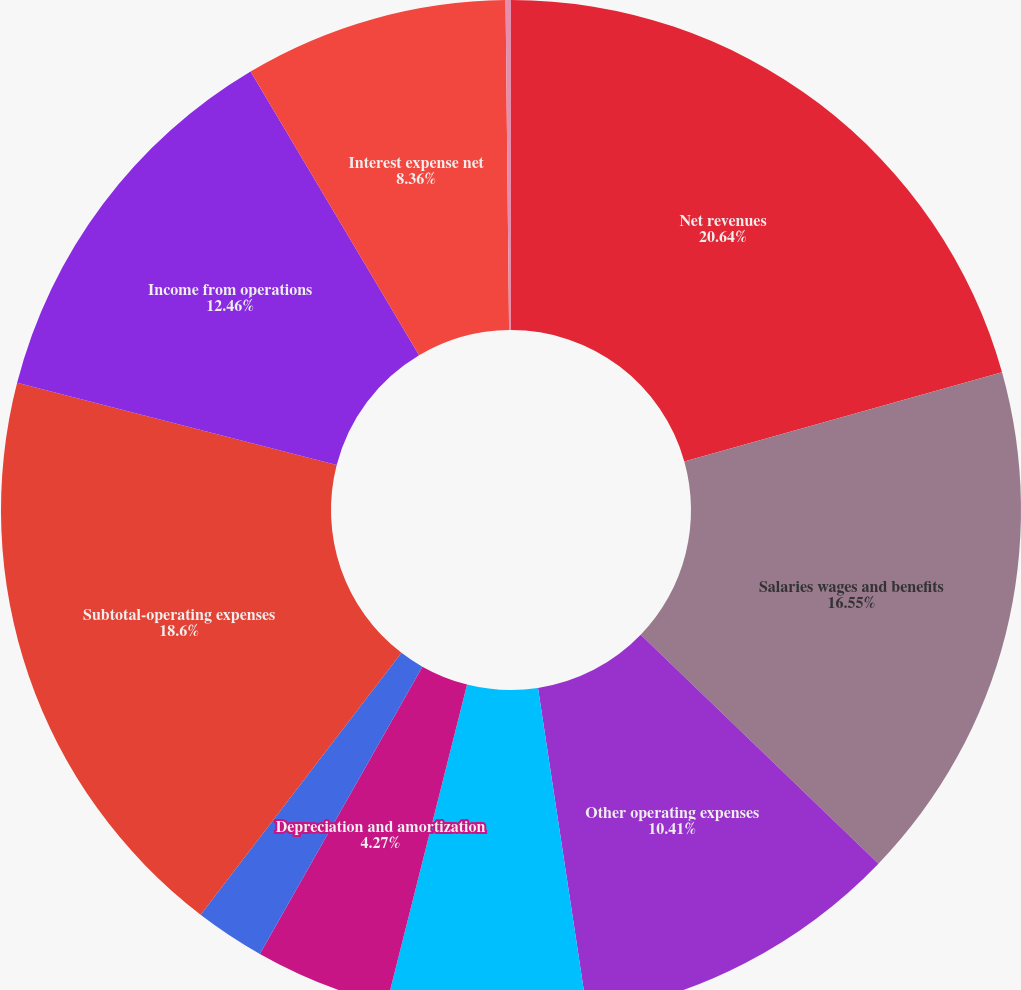<chart> <loc_0><loc_0><loc_500><loc_500><pie_chart><fcel>Net revenues<fcel>Salaries wages and benefits<fcel>Other operating expenses<fcel>Supplies expense<fcel>Depreciation and amortization<fcel>Lease and rental expense<fcel>Subtotal-operating expenses<fcel>Income from operations<fcel>Interest expense net<fcel>Other (income) expense net<nl><fcel>20.65%<fcel>16.55%<fcel>10.41%<fcel>6.32%<fcel>4.27%<fcel>2.22%<fcel>18.6%<fcel>12.46%<fcel>8.36%<fcel>0.17%<nl></chart> 